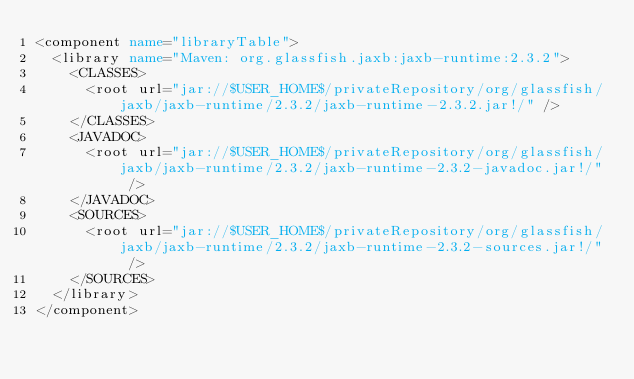<code> <loc_0><loc_0><loc_500><loc_500><_XML_><component name="libraryTable">
  <library name="Maven: org.glassfish.jaxb:jaxb-runtime:2.3.2">
    <CLASSES>
      <root url="jar://$USER_HOME$/privateRepository/org/glassfish/jaxb/jaxb-runtime/2.3.2/jaxb-runtime-2.3.2.jar!/" />
    </CLASSES>
    <JAVADOC>
      <root url="jar://$USER_HOME$/privateRepository/org/glassfish/jaxb/jaxb-runtime/2.3.2/jaxb-runtime-2.3.2-javadoc.jar!/" />
    </JAVADOC>
    <SOURCES>
      <root url="jar://$USER_HOME$/privateRepository/org/glassfish/jaxb/jaxb-runtime/2.3.2/jaxb-runtime-2.3.2-sources.jar!/" />
    </SOURCES>
  </library>
</component></code> 